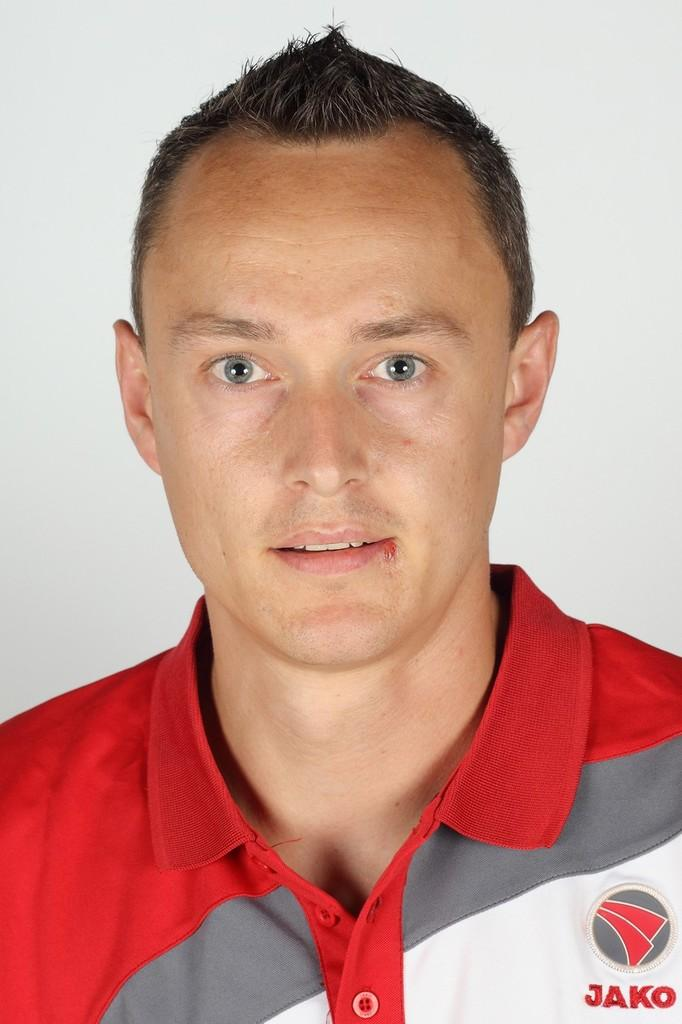<image>
Describe the image concisely. Jako reads the patch sewn onto the front of this shirt. 